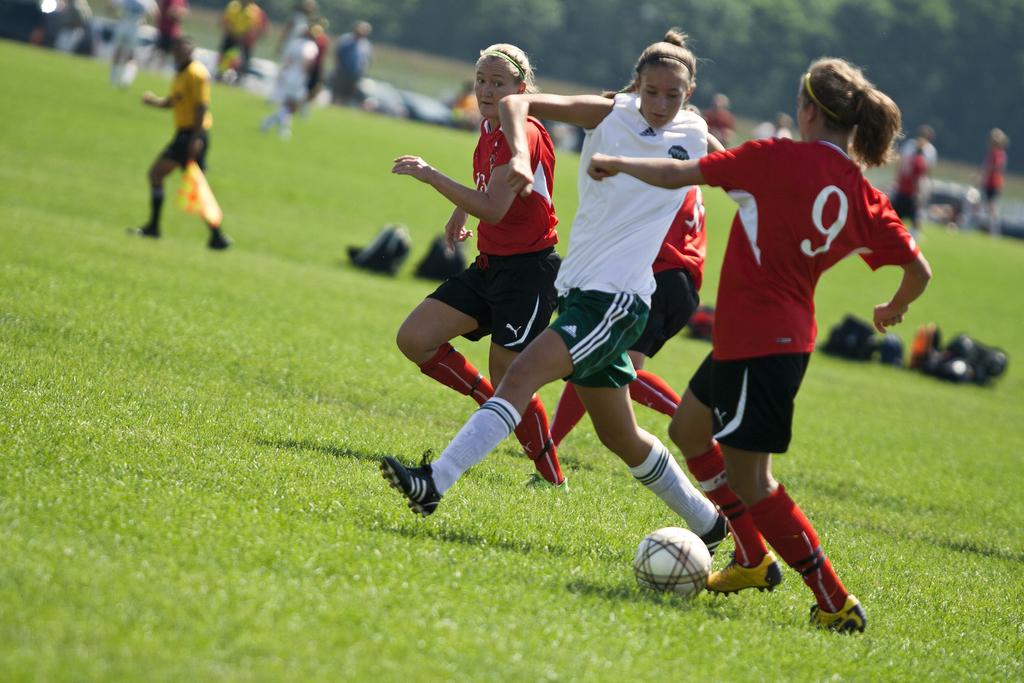What number is the player in red?
Your answer should be very brief. 9. 9 red player?
Give a very brief answer. Yes. 